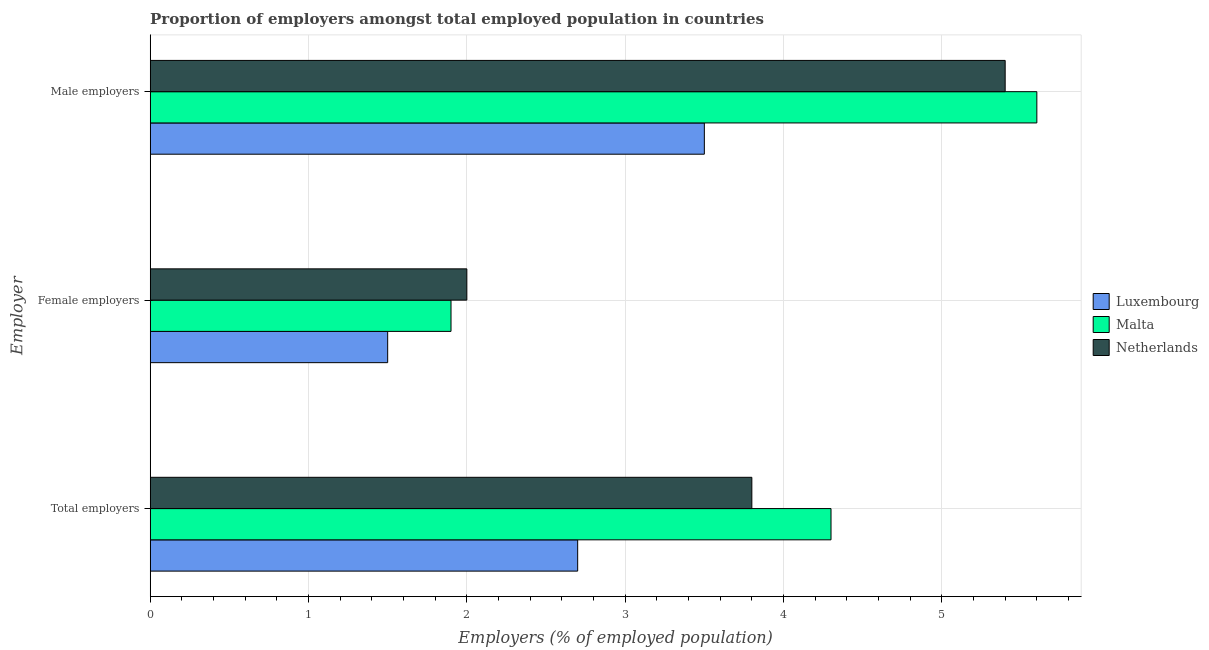What is the label of the 2nd group of bars from the top?
Offer a terse response. Female employers. What is the percentage of female employers in Netherlands?
Make the answer very short. 2. Across all countries, what is the maximum percentage of total employers?
Ensure brevity in your answer.  4.3. In which country was the percentage of total employers maximum?
Offer a very short reply. Malta. In which country was the percentage of total employers minimum?
Keep it short and to the point. Luxembourg. What is the total percentage of total employers in the graph?
Your answer should be very brief. 10.8. What is the difference between the percentage of male employers in Netherlands and that in Malta?
Give a very brief answer. -0.2. What is the difference between the percentage of female employers in Malta and the percentage of total employers in Netherlands?
Provide a succinct answer. -1.9. What is the average percentage of total employers per country?
Your answer should be very brief. 3.6. What is the difference between the percentage of male employers and percentage of female employers in Netherlands?
Provide a succinct answer. 3.4. In how many countries, is the percentage of female employers greater than 2.8 %?
Provide a succinct answer. 0. What is the ratio of the percentage of total employers in Luxembourg to that in Malta?
Offer a very short reply. 0.63. Is the percentage of total employers in Luxembourg less than that in Netherlands?
Provide a succinct answer. Yes. Is the difference between the percentage of male employers in Malta and Netherlands greater than the difference between the percentage of total employers in Malta and Netherlands?
Offer a terse response. No. What is the difference between the highest and the second highest percentage of male employers?
Ensure brevity in your answer.  0.2. What is the difference between the highest and the lowest percentage of total employers?
Provide a short and direct response. 1.6. In how many countries, is the percentage of total employers greater than the average percentage of total employers taken over all countries?
Offer a very short reply. 2. Is the sum of the percentage of total employers in Netherlands and Malta greater than the maximum percentage of male employers across all countries?
Keep it short and to the point. Yes. What does the 2nd bar from the top in Female employers represents?
Provide a succinct answer. Malta. Is it the case that in every country, the sum of the percentage of total employers and percentage of female employers is greater than the percentage of male employers?
Your answer should be very brief. Yes. How many bars are there?
Offer a terse response. 9. How many countries are there in the graph?
Ensure brevity in your answer.  3. Does the graph contain any zero values?
Provide a succinct answer. No. Where does the legend appear in the graph?
Provide a short and direct response. Center right. What is the title of the graph?
Give a very brief answer. Proportion of employers amongst total employed population in countries. What is the label or title of the X-axis?
Provide a short and direct response. Employers (% of employed population). What is the label or title of the Y-axis?
Offer a terse response. Employer. What is the Employers (% of employed population) of Luxembourg in Total employers?
Keep it short and to the point. 2.7. What is the Employers (% of employed population) of Malta in Total employers?
Offer a terse response. 4.3. What is the Employers (% of employed population) in Netherlands in Total employers?
Your answer should be very brief. 3.8. What is the Employers (% of employed population) of Malta in Female employers?
Give a very brief answer. 1.9. What is the Employers (% of employed population) in Malta in Male employers?
Your answer should be very brief. 5.6. What is the Employers (% of employed population) in Netherlands in Male employers?
Provide a short and direct response. 5.4. Across all Employer, what is the maximum Employers (% of employed population) of Malta?
Offer a very short reply. 5.6. Across all Employer, what is the maximum Employers (% of employed population) in Netherlands?
Your response must be concise. 5.4. Across all Employer, what is the minimum Employers (% of employed population) of Malta?
Provide a short and direct response. 1.9. What is the total Employers (% of employed population) in Netherlands in the graph?
Offer a very short reply. 11.2. What is the difference between the Employers (% of employed population) in Luxembourg in Total employers and that in Male employers?
Provide a short and direct response. -0.8. What is the difference between the Employers (% of employed population) in Malta in Total employers and that in Male employers?
Your answer should be compact. -1.3. What is the difference between the Employers (% of employed population) in Luxembourg in Female employers and that in Male employers?
Provide a short and direct response. -2. What is the difference between the Employers (% of employed population) of Malta in Female employers and that in Male employers?
Give a very brief answer. -3.7. What is the difference between the Employers (% of employed population) in Luxembourg in Total employers and the Employers (% of employed population) in Netherlands in Female employers?
Give a very brief answer. 0.7. What is the difference between the Employers (% of employed population) of Malta in Total employers and the Employers (% of employed population) of Netherlands in Female employers?
Your response must be concise. 2.3. What is the difference between the Employers (% of employed population) in Luxembourg in Total employers and the Employers (% of employed population) in Malta in Male employers?
Your answer should be very brief. -2.9. What is the difference between the Employers (% of employed population) of Luxembourg in Total employers and the Employers (% of employed population) of Netherlands in Male employers?
Offer a very short reply. -2.7. What is the difference between the Employers (% of employed population) in Luxembourg in Female employers and the Employers (% of employed population) in Malta in Male employers?
Provide a succinct answer. -4.1. What is the difference between the Employers (% of employed population) of Luxembourg in Female employers and the Employers (% of employed population) of Netherlands in Male employers?
Your answer should be compact. -3.9. What is the average Employers (% of employed population) of Luxembourg per Employer?
Ensure brevity in your answer.  2.57. What is the average Employers (% of employed population) in Malta per Employer?
Ensure brevity in your answer.  3.93. What is the average Employers (% of employed population) of Netherlands per Employer?
Provide a short and direct response. 3.73. What is the difference between the Employers (% of employed population) in Luxembourg and Employers (% of employed population) in Netherlands in Total employers?
Give a very brief answer. -1.1. What is the difference between the Employers (% of employed population) of Malta and Employers (% of employed population) of Netherlands in Total employers?
Keep it short and to the point. 0.5. What is the difference between the Employers (% of employed population) of Luxembourg and Employers (% of employed population) of Malta in Female employers?
Offer a terse response. -0.4. What is the difference between the Employers (% of employed population) of Luxembourg and Employers (% of employed population) of Malta in Male employers?
Provide a short and direct response. -2.1. What is the difference between the Employers (% of employed population) of Luxembourg and Employers (% of employed population) of Netherlands in Male employers?
Make the answer very short. -1.9. What is the difference between the Employers (% of employed population) of Malta and Employers (% of employed population) of Netherlands in Male employers?
Your answer should be compact. 0.2. What is the ratio of the Employers (% of employed population) in Luxembourg in Total employers to that in Female employers?
Your response must be concise. 1.8. What is the ratio of the Employers (% of employed population) in Malta in Total employers to that in Female employers?
Provide a succinct answer. 2.26. What is the ratio of the Employers (% of employed population) in Netherlands in Total employers to that in Female employers?
Your answer should be compact. 1.9. What is the ratio of the Employers (% of employed population) in Luxembourg in Total employers to that in Male employers?
Make the answer very short. 0.77. What is the ratio of the Employers (% of employed population) of Malta in Total employers to that in Male employers?
Keep it short and to the point. 0.77. What is the ratio of the Employers (% of employed population) of Netherlands in Total employers to that in Male employers?
Keep it short and to the point. 0.7. What is the ratio of the Employers (% of employed population) of Luxembourg in Female employers to that in Male employers?
Ensure brevity in your answer.  0.43. What is the ratio of the Employers (% of employed population) of Malta in Female employers to that in Male employers?
Your answer should be very brief. 0.34. What is the ratio of the Employers (% of employed population) in Netherlands in Female employers to that in Male employers?
Make the answer very short. 0.37. What is the difference between the highest and the second highest Employers (% of employed population) in Luxembourg?
Your answer should be very brief. 0.8. What is the difference between the highest and the second highest Employers (% of employed population) in Malta?
Keep it short and to the point. 1.3. What is the difference between the highest and the lowest Employers (% of employed population) in Malta?
Ensure brevity in your answer.  3.7. What is the difference between the highest and the lowest Employers (% of employed population) of Netherlands?
Provide a short and direct response. 3.4. 